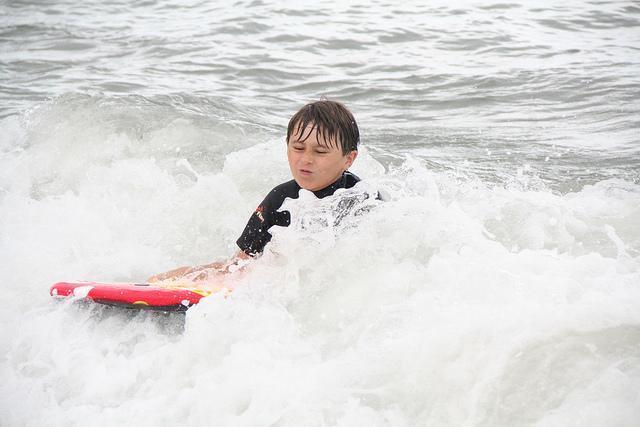How many cars is this engine pulling?
Give a very brief answer. 0. 